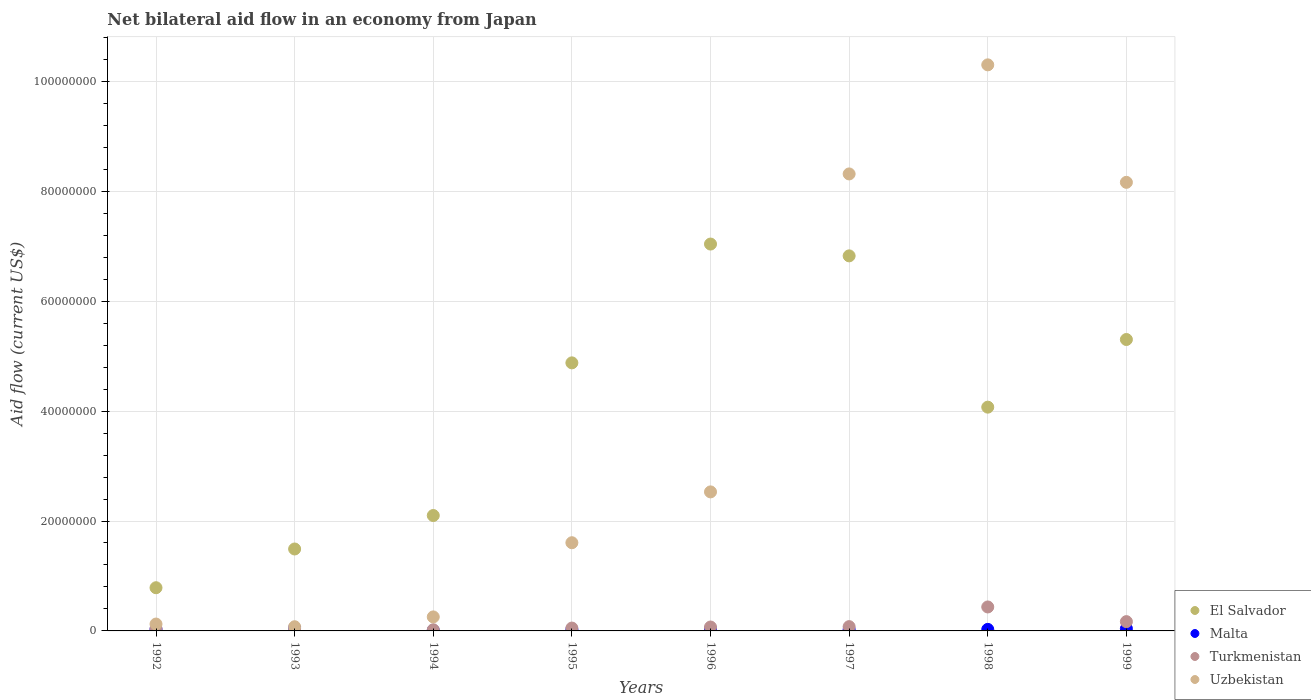What is the net bilateral aid flow in Malta in 1993?
Provide a succinct answer. 5.30e+05. Across all years, what is the maximum net bilateral aid flow in El Salvador?
Offer a very short reply. 7.04e+07. Across all years, what is the minimum net bilateral aid flow in Malta?
Provide a short and direct response. 9.00e+04. What is the total net bilateral aid flow in Turkmenistan in the graph?
Provide a short and direct response. 8.75e+06. What is the difference between the net bilateral aid flow in Malta in 1997 and that in 1998?
Keep it short and to the point. -2.00e+04. What is the difference between the net bilateral aid flow in Turkmenistan in 1997 and the net bilateral aid flow in Uzbekistan in 1995?
Ensure brevity in your answer.  -1.53e+07. What is the average net bilateral aid flow in El Salvador per year?
Offer a terse response. 4.06e+07. In the year 1993, what is the difference between the net bilateral aid flow in Malta and net bilateral aid flow in Uzbekistan?
Ensure brevity in your answer.  -2.30e+05. What is the ratio of the net bilateral aid flow in Turkmenistan in 1994 to that in 1995?
Provide a succinct answer. 0.4. Is the difference between the net bilateral aid flow in Malta in 1998 and 1999 greater than the difference between the net bilateral aid flow in Uzbekistan in 1998 and 1999?
Your response must be concise. No. What is the difference between the highest and the second highest net bilateral aid flow in Turkmenistan?
Your response must be concise. 2.67e+06. What is the difference between the highest and the lowest net bilateral aid flow in El Salvador?
Provide a short and direct response. 6.25e+07. In how many years, is the net bilateral aid flow in Malta greater than the average net bilateral aid flow in Malta taken over all years?
Offer a very short reply. 3. Is the sum of the net bilateral aid flow in Uzbekistan in 1993 and 1998 greater than the maximum net bilateral aid flow in Malta across all years?
Make the answer very short. Yes. Does the net bilateral aid flow in Turkmenistan monotonically increase over the years?
Offer a terse response. No. Is the net bilateral aid flow in Malta strictly greater than the net bilateral aid flow in El Salvador over the years?
Provide a short and direct response. No. Is the net bilateral aid flow in El Salvador strictly less than the net bilateral aid flow in Turkmenistan over the years?
Your answer should be very brief. No. How many dotlines are there?
Offer a terse response. 4. Does the graph contain grids?
Your answer should be very brief. Yes. Where does the legend appear in the graph?
Offer a very short reply. Bottom right. What is the title of the graph?
Ensure brevity in your answer.  Net bilateral aid flow in an economy from Japan. Does "El Salvador" appear as one of the legend labels in the graph?
Your response must be concise. Yes. What is the label or title of the X-axis?
Provide a short and direct response. Years. What is the Aid flow (current US$) in El Salvador in 1992?
Your answer should be compact. 7.86e+06. What is the Aid flow (current US$) of Uzbekistan in 1992?
Your answer should be compact. 1.25e+06. What is the Aid flow (current US$) in El Salvador in 1993?
Your answer should be very brief. 1.49e+07. What is the Aid flow (current US$) of Malta in 1993?
Offer a terse response. 5.30e+05. What is the Aid flow (current US$) of Uzbekistan in 1993?
Provide a short and direct response. 7.60e+05. What is the Aid flow (current US$) in El Salvador in 1994?
Provide a short and direct response. 2.10e+07. What is the Aid flow (current US$) of Malta in 1994?
Your response must be concise. 9.00e+04. What is the Aid flow (current US$) of Turkmenistan in 1994?
Your answer should be compact. 2.10e+05. What is the Aid flow (current US$) of Uzbekistan in 1994?
Give a very brief answer. 2.55e+06. What is the Aid flow (current US$) of El Salvador in 1995?
Your answer should be compact. 4.88e+07. What is the Aid flow (current US$) of Malta in 1995?
Provide a short and direct response. 2.40e+05. What is the Aid flow (current US$) in Turkmenistan in 1995?
Make the answer very short. 5.20e+05. What is the Aid flow (current US$) of Uzbekistan in 1995?
Your answer should be compact. 1.60e+07. What is the Aid flow (current US$) of El Salvador in 1996?
Offer a very short reply. 7.04e+07. What is the Aid flow (current US$) of Turkmenistan in 1996?
Your response must be concise. 7.10e+05. What is the Aid flow (current US$) in Uzbekistan in 1996?
Your answer should be compact. 2.53e+07. What is the Aid flow (current US$) in El Salvador in 1997?
Your response must be concise. 6.82e+07. What is the Aid flow (current US$) of Turkmenistan in 1997?
Keep it short and to the point. 7.80e+05. What is the Aid flow (current US$) of Uzbekistan in 1997?
Keep it short and to the point. 8.32e+07. What is the Aid flow (current US$) of El Salvador in 1998?
Keep it short and to the point. 4.07e+07. What is the Aid flow (current US$) in Turkmenistan in 1998?
Your answer should be compact. 4.36e+06. What is the Aid flow (current US$) in Uzbekistan in 1998?
Keep it short and to the point. 1.03e+08. What is the Aid flow (current US$) in El Salvador in 1999?
Your answer should be compact. 5.30e+07. What is the Aid flow (current US$) in Malta in 1999?
Ensure brevity in your answer.  4.20e+05. What is the Aid flow (current US$) of Turkmenistan in 1999?
Provide a short and direct response. 1.69e+06. What is the Aid flow (current US$) of Uzbekistan in 1999?
Offer a terse response. 8.16e+07. Across all years, what is the maximum Aid flow (current US$) of El Salvador?
Your answer should be compact. 7.04e+07. Across all years, what is the maximum Aid flow (current US$) in Malta?
Make the answer very short. 5.30e+05. Across all years, what is the maximum Aid flow (current US$) of Turkmenistan?
Provide a succinct answer. 4.36e+06. Across all years, what is the maximum Aid flow (current US$) in Uzbekistan?
Your response must be concise. 1.03e+08. Across all years, what is the minimum Aid flow (current US$) in El Salvador?
Offer a very short reply. 7.86e+06. Across all years, what is the minimum Aid flow (current US$) in Malta?
Your answer should be compact. 9.00e+04. Across all years, what is the minimum Aid flow (current US$) in Uzbekistan?
Provide a succinct answer. 7.60e+05. What is the total Aid flow (current US$) of El Salvador in the graph?
Your response must be concise. 3.25e+08. What is the total Aid flow (current US$) in Malta in the graph?
Keep it short and to the point. 2.49e+06. What is the total Aid flow (current US$) in Turkmenistan in the graph?
Keep it short and to the point. 8.75e+06. What is the total Aid flow (current US$) of Uzbekistan in the graph?
Offer a very short reply. 3.14e+08. What is the difference between the Aid flow (current US$) in El Salvador in 1992 and that in 1993?
Your answer should be compact. -7.05e+06. What is the difference between the Aid flow (current US$) in Malta in 1992 and that in 1993?
Offer a terse response. -2.30e+05. What is the difference between the Aid flow (current US$) of Turkmenistan in 1992 and that in 1993?
Ensure brevity in your answer.  3.00e+05. What is the difference between the Aid flow (current US$) of El Salvador in 1992 and that in 1994?
Your response must be concise. -1.31e+07. What is the difference between the Aid flow (current US$) of Uzbekistan in 1992 and that in 1994?
Your answer should be very brief. -1.30e+06. What is the difference between the Aid flow (current US$) of El Salvador in 1992 and that in 1995?
Provide a short and direct response. -4.09e+07. What is the difference between the Aid flow (current US$) in Malta in 1992 and that in 1995?
Offer a very short reply. 6.00e+04. What is the difference between the Aid flow (current US$) in Uzbekistan in 1992 and that in 1995?
Offer a very short reply. -1.48e+07. What is the difference between the Aid flow (current US$) of El Salvador in 1992 and that in 1996?
Ensure brevity in your answer.  -6.25e+07. What is the difference between the Aid flow (current US$) in Turkmenistan in 1992 and that in 1996?
Make the answer very short. -3.20e+05. What is the difference between the Aid flow (current US$) of Uzbekistan in 1992 and that in 1996?
Your answer should be compact. -2.40e+07. What is the difference between the Aid flow (current US$) in El Salvador in 1992 and that in 1997?
Your response must be concise. -6.04e+07. What is the difference between the Aid flow (current US$) of Turkmenistan in 1992 and that in 1997?
Your response must be concise. -3.90e+05. What is the difference between the Aid flow (current US$) of Uzbekistan in 1992 and that in 1997?
Offer a terse response. -8.19e+07. What is the difference between the Aid flow (current US$) in El Salvador in 1992 and that in 1998?
Your answer should be very brief. -3.29e+07. What is the difference between the Aid flow (current US$) in Malta in 1992 and that in 1998?
Provide a short and direct response. 2.00e+04. What is the difference between the Aid flow (current US$) in Turkmenistan in 1992 and that in 1998?
Your answer should be compact. -3.97e+06. What is the difference between the Aid flow (current US$) in Uzbekistan in 1992 and that in 1998?
Keep it short and to the point. -1.02e+08. What is the difference between the Aid flow (current US$) in El Salvador in 1992 and that in 1999?
Offer a terse response. -4.52e+07. What is the difference between the Aid flow (current US$) of Turkmenistan in 1992 and that in 1999?
Provide a short and direct response. -1.30e+06. What is the difference between the Aid flow (current US$) in Uzbekistan in 1992 and that in 1999?
Your answer should be compact. -8.04e+07. What is the difference between the Aid flow (current US$) of El Salvador in 1993 and that in 1994?
Offer a terse response. -6.09e+06. What is the difference between the Aid flow (current US$) in Malta in 1993 and that in 1994?
Provide a short and direct response. 4.40e+05. What is the difference between the Aid flow (current US$) of Turkmenistan in 1993 and that in 1994?
Give a very brief answer. -1.20e+05. What is the difference between the Aid flow (current US$) of Uzbekistan in 1993 and that in 1994?
Offer a very short reply. -1.79e+06. What is the difference between the Aid flow (current US$) of El Salvador in 1993 and that in 1995?
Your response must be concise. -3.39e+07. What is the difference between the Aid flow (current US$) of Malta in 1993 and that in 1995?
Give a very brief answer. 2.90e+05. What is the difference between the Aid flow (current US$) of Turkmenistan in 1993 and that in 1995?
Give a very brief answer. -4.30e+05. What is the difference between the Aid flow (current US$) of Uzbekistan in 1993 and that in 1995?
Provide a short and direct response. -1.53e+07. What is the difference between the Aid flow (current US$) of El Salvador in 1993 and that in 1996?
Your answer should be very brief. -5.55e+07. What is the difference between the Aid flow (current US$) of Turkmenistan in 1993 and that in 1996?
Make the answer very short. -6.20e+05. What is the difference between the Aid flow (current US$) in Uzbekistan in 1993 and that in 1996?
Your response must be concise. -2.45e+07. What is the difference between the Aid flow (current US$) in El Salvador in 1993 and that in 1997?
Your answer should be compact. -5.33e+07. What is the difference between the Aid flow (current US$) in Malta in 1993 and that in 1997?
Provide a short and direct response. 2.70e+05. What is the difference between the Aid flow (current US$) in Turkmenistan in 1993 and that in 1997?
Your answer should be compact. -6.90e+05. What is the difference between the Aid flow (current US$) in Uzbekistan in 1993 and that in 1997?
Your answer should be very brief. -8.24e+07. What is the difference between the Aid flow (current US$) of El Salvador in 1993 and that in 1998?
Your answer should be very brief. -2.58e+07. What is the difference between the Aid flow (current US$) of Malta in 1993 and that in 1998?
Your response must be concise. 2.50e+05. What is the difference between the Aid flow (current US$) in Turkmenistan in 1993 and that in 1998?
Offer a very short reply. -4.27e+06. What is the difference between the Aid flow (current US$) in Uzbekistan in 1993 and that in 1998?
Offer a terse response. -1.02e+08. What is the difference between the Aid flow (current US$) in El Salvador in 1993 and that in 1999?
Offer a very short reply. -3.81e+07. What is the difference between the Aid flow (current US$) of Turkmenistan in 1993 and that in 1999?
Ensure brevity in your answer.  -1.60e+06. What is the difference between the Aid flow (current US$) of Uzbekistan in 1993 and that in 1999?
Your answer should be very brief. -8.09e+07. What is the difference between the Aid flow (current US$) of El Salvador in 1994 and that in 1995?
Offer a terse response. -2.78e+07. What is the difference between the Aid flow (current US$) in Turkmenistan in 1994 and that in 1995?
Make the answer very short. -3.10e+05. What is the difference between the Aid flow (current US$) of Uzbekistan in 1994 and that in 1995?
Your response must be concise. -1.35e+07. What is the difference between the Aid flow (current US$) of El Salvador in 1994 and that in 1996?
Provide a short and direct response. -4.94e+07. What is the difference between the Aid flow (current US$) in Malta in 1994 and that in 1996?
Keep it short and to the point. -2.80e+05. What is the difference between the Aid flow (current US$) in Turkmenistan in 1994 and that in 1996?
Offer a terse response. -5.00e+05. What is the difference between the Aid flow (current US$) in Uzbekistan in 1994 and that in 1996?
Your answer should be very brief. -2.28e+07. What is the difference between the Aid flow (current US$) in El Salvador in 1994 and that in 1997?
Keep it short and to the point. -4.72e+07. What is the difference between the Aid flow (current US$) in Turkmenistan in 1994 and that in 1997?
Offer a very short reply. -5.70e+05. What is the difference between the Aid flow (current US$) in Uzbekistan in 1994 and that in 1997?
Your answer should be compact. -8.06e+07. What is the difference between the Aid flow (current US$) of El Salvador in 1994 and that in 1998?
Give a very brief answer. -1.97e+07. What is the difference between the Aid flow (current US$) in Malta in 1994 and that in 1998?
Your answer should be very brief. -1.90e+05. What is the difference between the Aid flow (current US$) of Turkmenistan in 1994 and that in 1998?
Give a very brief answer. -4.15e+06. What is the difference between the Aid flow (current US$) of Uzbekistan in 1994 and that in 1998?
Your response must be concise. -1.00e+08. What is the difference between the Aid flow (current US$) of El Salvador in 1994 and that in 1999?
Make the answer very short. -3.20e+07. What is the difference between the Aid flow (current US$) in Malta in 1994 and that in 1999?
Your answer should be compact. -3.30e+05. What is the difference between the Aid flow (current US$) of Turkmenistan in 1994 and that in 1999?
Keep it short and to the point. -1.48e+06. What is the difference between the Aid flow (current US$) in Uzbekistan in 1994 and that in 1999?
Ensure brevity in your answer.  -7.91e+07. What is the difference between the Aid flow (current US$) of El Salvador in 1995 and that in 1996?
Give a very brief answer. -2.16e+07. What is the difference between the Aid flow (current US$) of Turkmenistan in 1995 and that in 1996?
Your answer should be very brief. -1.90e+05. What is the difference between the Aid flow (current US$) in Uzbekistan in 1995 and that in 1996?
Provide a short and direct response. -9.25e+06. What is the difference between the Aid flow (current US$) of El Salvador in 1995 and that in 1997?
Offer a very short reply. -1.95e+07. What is the difference between the Aid flow (current US$) of Malta in 1995 and that in 1997?
Make the answer very short. -2.00e+04. What is the difference between the Aid flow (current US$) in Uzbekistan in 1995 and that in 1997?
Give a very brief answer. -6.71e+07. What is the difference between the Aid flow (current US$) in El Salvador in 1995 and that in 1998?
Your answer should be compact. 8.06e+06. What is the difference between the Aid flow (current US$) of Turkmenistan in 1995 and that in 1998?
Ensure brevity in your answer.  -3.84e+06. What is the difference between the Aid flow (current US$) of Uzbekistan in 1995 and that in 1998?
Give a very brief answer. -8.70e+07. What is the difference between the Aid flow (current US$) of El Salvador in 1995 and that in 1999?
Give a very brief answer. -4.25e+06. What is the difference between the Aid flow (current US$) in Malta in 1995 and that in 1999?
Keep it short and to the point. -1.80e+05. What is the difference between the Aid flow (current US$) of Turkmenistan in 1995 and that in 1999?
Provide a short and direct response. -1.17e+06. What is the difference between the Aid flow (current US$) of Uzbekistan in 1995 and that in 1999?
Ensure brevity in your answer.  -6.56e+07. What is the difference between the Aid flow (current US$) of El Salvador in 1996 and that in 1997?
Give a very brief answer. 2.15e+06. What is the difference between the Aid flow (current US$) in Malta in 1996 and that in 1997?
Your answer should be compact. 1.10e+05. What is the difference between the Aid flow (current US$) in Uzbekistan in 1996 and that in 1997?
Make the answer very short. -5.79e+07. What is the difference between the Aid flow (current US$) of El Salvador in 1996 and that in 1998?
Offer a terse response. 2.97e+07. What is the difference between the Aid flow (current US$) in Turkmenistan in 1996 and that in 1998?
Provide a succinct answer. -3.65e+06. What is the difference between the Aid flow (current US$) in Uzbekistan in 1996 and that in 1998?
Keep it short and to the point. -7.77e+07. What is the difference between the Aid flow (current US$) of El Salvador in 1996 and that in 1999?
Make the answer very short. 1.74e+07. What is the difference between the Aid flow (current US$) of Malta in 1996 and that in 1999?
Offer a terse response. -5.00e+04. What is the difference between the Aid flow (current US$) of Turkmenistan in 1996 and that in 1999?
Your answer should be compact. -9.80e+05. What is the difference between the Aid flow (current US$) in Uzbekistan in 1996 and that in 1999?
Keep it short and to the point. -5.63e+07. What is the difference between the Aid flow (current US$) in El Salvador in 1997 and that in 1998?
Keep it short and to the point. 2.75e+07. What is the difference between the Aid flow (current US$) of Turkmenistan in 1997 and that in 1998?
Your answer should be compact. -3.58e+06. What is the difference between the Aid flow (current US$) of Uzbekistan in 1997 and that in 1998?
Keep it short and to the point. -1.98e+07. What is the difference between the Aid flow (current US$) in El Salvador in 1997 and that in 1999?
Your response must be concise. 1.52e+07. What is the difference between the Aid flow (current US$) in Malta in 1997 and that in 1999?
Give a very brief answer. -1.60e+05. What is the difference between the Aid flow (current US$) in Turkmenistan in 1997 and that in 1999?
Your response must be concise. -9.10e+05. What is the difference between the Aid flow (current US$) of Uzbekistan in 1997 and that in 1999?
Ensure brevity in your answer.  1.53e+06. What is the difference between the Aid flow (current US$) in El Salvador in 1998 and that in 1999?
Provide a succinct answer. -1.23e+07. What is the difference between the Aid flow (current US$) of Turkmenistan in 1998 and that in 1999?
Make the answer very short. 2.67e+06. What is the difference between the Aid flow (current US$) of Uzbekistan in 1998 and that in 1999?
Your response must be concise. 2.14e+07. What is the difference between the Aid flow (current US$) of El Salvador in 1992 and the Aid flow (current US$) of Malta in 1993?
Your answer should be compact. 7.33e+06. What is the difference between the Aid flow (current US$) of El Salvador in 1992 and the Aid flow (current US$) of Turkmenistan in 1993?
Give a very brief answer. 7.77e+06. What is the difference between the Aid flow (current US$) of El Salvador in 1992 and the Aid flow (current US$) of Uzbekistan in 1993?
Your response must be concise. 7.10e+06. What is the difference between the Aid flow (current US$) of Malta in 1992 and the Aid flow (current US$) of Turkmenistan in 1993?
Your answer should be compact. 2.10e+05. What is the difference between the Aid flow (current US$) in Malta in 1992 and the Aid flow (current US$) in Uzbekistan in 1993?
Provide a succinct answer. -4.60e+05. What is the difference between the Aid flow (current US$) in Turkmenistan in 1992 and the Aid flow (current US$) in Uzbekistan in 1993?
Provide a short and direct response. -3.70e+05. What is the difference between the Aid flow (current US$) in El Salvador in 1992 and the Aid flow (current US$) in Malta in 1994?
Give a very brief answer. 7.77e+06. What is the difference between the Aid flow (current US$) in El Salvador in 1992 and the Aid flow (current US$) in Turkmenistan in 1994?
Your answer should be very brief. 7.65e+06. What is the difference between the Aid flow (current US$) of El Salvador in 1992 and the Aid flow (current US$) of Uzbekistan in 1994?
Offer a terse response. 5.31e+06. What is the difference between the Aid flow (current US$) of Malta in 1992 and the Aid flow (current US$) of Uzbekistan in 1994?
Provide a succinct answer. -2.25e+06. What is the difference between the Aid flow (current US$) of Turkmenistan in 1992 and the Aid flow (current US$) of Uzbekistan in 1994?
Ensure brevity in your answer.  -2.16e+06. What is the difference between the Aid flow (current US$) of El Salvador in 1992 and the Aid flow (current US$) of Malta in 1995?
Give a very brief answer. 7.62e+06. What is the difference between the Aid flow (current US$) in El Salvador in 1992 and the Aid flow (current US$) in Turkmenistan in 1995?
Provide a short and direct response. 7.34e+06. What is the difference between the Aid flow (current US$) in El Salvador in 1992 and the Aid flow (current US$) in Uzbekistan in 1995?
Provide a succinct answer. -8.19e+06. What is the difference between the Aid flow (current US$) of Malta in 1992 and the Aid flow (current US$) of Uzbekistan in 1995?
Provide a short and direct response. -1.58e+07. What is the difference between the Aid flow (current US$) of Turkmenistan in 1992 and the Aid flow (current US$) of Uzbekistan in 1995?
Offer a terse response. -1.57e+07. What is the difference between the Aid flow (current US$) in El Salvador in 1992 and the Aid flow (current US$) in Malta in 1996?
Make the answer very short. 7.49e+06. What is the difference between the Aid flow (current US$) in El Salvador in 1992 and the Aid flow (current US$) in Turkmenistan in 1996?
Give a very brief answer. 7.15e+06. What is the difference between the Aid flow (current US$) in El Salvador in 1992 and the Aid flow (current US$) in Uzbekistan in 1996?
Offer a terse response. -1.74e+07. What is the difference between the Aid flow (current US$) of Malta in 1992 and the Aid flow (current US$) of Turkmenistan in 1996?
Keep it short and to the point. -4.10e+05. What is the difference between the Aid flow (current US$) in Malta in 1992 and the Aid flow (current US$) in Uzbekistan in 1996?
Provide a succinct answer. -2.50e+07. What is the difference between the Aid flow (current US$) in Turkmenistan in 1992 and the Aid flow (current US$) in Uzbekistan in 1996?
Your answer should be compact. -2.49e+07. What is the difference between the Aid flow (current US$) in El Salvador in 1992 and the Aid flow (current US$) in Malta in 1997?
Offer a terse response. 7.60e+06. What is the difference between the Aid flow (current US$) of El Salvador in 1992 and the Aid flow (current US$) of Turkmenistan in 1997?
Offer a very short reply. 7.08e+06. What is the difference between the Aid flow (current US$) in El Salvador in 1992 and the Aid flow (current US$) in Uzbekistan in 1997?
Your response must be concise. -7.53e+07. What is the difference between the Aid flow (current US$) of Malta in 1992 and the Aid flow (current US$) of Turkmenistan in 1997?
Ensure brevity in your answer.  -4.80e+05. What is the difference between the Aid flow (current US$) in Malta in 1992 and the Aid flow (current US$) in Uzbekistan in 1997?
Provide a short and direct response. -8.29e+07. What is the difference between the Aid flow (current US$) in Turkmenistan in 1992 and the Aid flow (current US$) in Uzbekistan in 1997?
Your answer should be compact. -8.28e+07. What is the difference between the Aid flow (current US$) in El Salvador in 1992 and the Aid flow (current US$) in Malta in 1998?
Your answer should be compact. 7.58e+06. What is the difference between the Aid flow (current US$) of El Salvador in 1992 and the Aid flow (current US$) of Turkmenistan in 1998?
Your response must be concise. 3.50e+06. What is the difference between the Aid flow (current US$) of El Salvador in 1992 and the Aid flow (current US$) of Uzbekistan in 1998?
Your answer should be very brief. -9.52e+07. What is the difference between the Aid flow (current US$) of Malta in 1992 and the Aid flow (current US$) of Turkmenistan in 1998?
Keep it short and to the point. -4.06e+06. What is the difference between the Aid flow (current US$) in Malta in 1992 and the Aid flow (current US$) in Uzbekistan in 1998?
Provide a succinct answer. -1.03e+08. What is the difference between the Aid flow (current US$) in Turkmenistan in 1992 and the Aid flow (current US$) in Uzbekistan in 1998?
Provide a short and direct response. -1.03e+08. What is the difference between the Aid flow (current US$) of El Salvador in 1992 and the Aid flow (current US$) of Malta in 1999?
Your response must be concise. 7.44e+06. What is the difference between the Aid flow (current US$) of El Salvador in 1992 and the Aid flow (current US$) of Turkmenistan in 1999?
Make the answer very short. 6.17e+06. What is the difference between the Aid flow (current US$) in El Salvador in 1992 and the Aid flow (current US$) in Uzbekistan in 1999?
Keep it short and to the point. -7.38e+07. What is the difference between the Aid flow (current US$) of Malta in 1992 and the Aid flow (current US$) of Turkmenistan in 1999?
Offer a terse response. -1.39e+06. What is the difference between the Aid flow (current US$) in Malta in 1992 and the Aid flow (current US$) in Uzbekistan in 1999?
Ensure brevity in your answer.  -8.13e+07. What is the difference between the Aid flow (current US$) of Turkmenistan in 1992 and the Aid flow (current US$) of Uzbekistan in 1999?
Your answer should be very brief. -8.12e+07. What is the difference between the Aid flow (current US$) in El Salvador in 1993 and the Aid flow (current US$) in Malta in 1994?
Offer a terse response. 1.48e+07. What is the difference between the Aid flow (current US$) in El Salvador in 1993 and the Aid flow (current US$) in Turkmenistan in 1994?
Give a very brief answer. 1.47e+07. What is the difference between the Aid flow (current US$) in El Salvador in 1993 and the Aid flow (current US$) in Uzbekistan in 1994?
Provide a short and direct response. 1.24e+07. What is the difference between the Aid flow (current US$) of Malta in 1993 and the Aid flow (current US$) of Turkmenistan in 1994?
Provide a short and direct response. 3.20e+05. What is the difference between the Aid flow (current US$) in Malta in 1993 and the Aid flow (current US$) in Uzbekistan in 1994?
Offer a terse response. -2.02e+06. What is the difference between the Aid flow (current US$) in Turkmenistan in 1993 and the Aid flow (current US$) in Uzbekistan in 1994?
Ensure brevity in your answer.  -2.46e+06. What is the difference between the Aid flow (current US$) of El Salvador in 1993 and the Aid flow (current US$) of Malta in 1995?
Ensure brevity in your answer.  1.47e+07. What is the difference between the Aid flow (current US$) in El Salvador in 1993 and the Aid flow (current US$) in Turkmenistan in 1995?
Your answer should be very brief. 1.44e+07. What is the difference between the Aid flow (current US$) of El Salvador in 1993 and the Aid flow (current US$) of Uzbekistan in 1995?
Give a very brief answer. -1.14e+06. What is the difference between the Aid flow (current US$) in Malta in 1993 and the Aid flow (current US$) in Uzbekistan in 1995?
Offer a terse response. -1.55e+07. What is the difference between the Aid flow (current US$) of Turkmenistan in 1993 and the Aid flow (current US$) of Uzbekistan in 1995?
Your response must be concise. -1.60e+07. What is the difference between the Aid flow (current US$) of El Salvador in 1993 and the Aid flow (current US$) of Malta in 1996?
Give a very brief answer. 1.45e+07. What is the difference between the Aid flow (current US$) in El Salvador in 1993 and the Aid flow (current US$) in Turkmenistan in 1996?
Your answer should be very brief. 1.42e+07. What is the difference between the Aid flow (current US$) of El Salvador in 1993 and the Aid flow (current US$) of Uzbekistan in 1996?
Your response must be concise. -1.04e+07. What is the difference between the Aid flow (current US$) in Malta in 1993 and the Aid flow (current US$) in Uzbekistan in 1996?
Ensure brevity in your answer.  -2.48e+07. What is the difference between the Aid flow (current US$) in Turkmenistan in 1993 and the Aid flow (current US$) in Uzbekistan in 1996?
Provide a short and direct response. -2.52e+07. What is the difference between the Aid flow (current US$) in El Salvador in 1993 and the Aid flow (current US$) in Malta in 1997?
Your response must be concise. 1.46e+07. What is the difference between the Aid flow (current US$) of El Salvador in 1993 and the Aid flow (current US$) of Turkmenistan in 1997?
Make the answer very short. 1.41e+07. What is the difference between the Aid flow (current US$) of El Salvador in 1993 and the Aid flow (current US$) of Uzbekistan in 1997?
Offer a terse response. -6.82e+07. What is the difference between the Aid flow (current US$) in Malta in 1993 and the Aid flow (current US$) in Turkmenistan in 1997?
Keep it short and to the point. -2.50e+05. What is the difference between the Aid flow (current US$) of Malta in 1993 and the Aid flow (current US$) of Uzbekistan in 1997?
Your answer should be very brief. -8.26e+07. What is the difference between the Aid flow (current US$) in Turkmenistan in 1993 and the Aid flow (current US$) in Uzbekistan in 1997?
Your response must be concise. -8.31e+07. What is the difference between the Aid flow (current US$) of El Salvador in 1993 and the Aid flow (current US$) of Malta in 1998?
Provide a succinct answer. 1.46e+07. What is the difference between the Aid flow (current US$) of El Salvador in 1993 and the Aid flow (current US$) of Turkmenistan in 1998?
Offer a terse response. 1.06e+07. What is the difference between the Aid flow (current US$) in El Salvador in 1993 and the Aid flow (current US$) in Uzbekistan in 1998?
Offer a very short reply. -8.81e+07. What is the difference between the Aid flow (current US$) in Malta in 1993 and the Aid flow (current US$) in Turkmenistan in 1998?
Offer a very short reply. -3.83e+06. What is the difference between the Aid flow (current US$) of Malta in 1993 and the Aid flow (current US$) of Uzbekistan in 1998?
Your answer should be very brief. -1.02e+08. What is the difference between the Aid flow (current US$) of Turkmenistan in 1993 and the Aid flow (current US$) of Uzbekistan in 1998?
Your response must be concise. -1.03e+08. What is the difference between the Aid flow (current US$) in El Salvador in 1993 and the Aid flow (current US$) in Malta in 1999?
Your answer should be compact. 1.45e+07. What is the difference between the Aid flow (current US$) in El Salvador in 1993 and the Aid flow (current US$) in Turkmenistan in 1999?
Offer a terse response. 1.32e+07. What is the difference between the Aid flow (current US$) in El Salvador in 1993 and the Aid flow (current US$) in Uzbekistan in 1999?
Your response must be concise. -6.67e+07. What is the difference between the Aid flow (current US$) in Malta in 1993 and the Aid flow (current US$) in Turkmenistan in 1999?
Keep it short and to the point. -1.16e+06. What is the difference between the Aid flow (current US$) of Malta in 1993 and the Aid flow (current US$) of Uzbekistan in 1999?
Your answer should be compact. -8.11e+07. What is the difference between the Aid flow (current US$) in Turkmenistan in 1993 and the Aid flow (current US$) in Uzbekistan in 1999?
Provide a succinct answer. -8.15e+07. What is the difference between the Aid flow (current US$) in El Salvador in 1994 and the Aid flow (current US$) in Malta in 1995?
Your answer should be compact. 2.08e+07. What is the difference between the Aid flow (current US$) in El Salvador in 1994 and the Aid flow (current US$) in Turkmenistan in 1995?
Provide a short and direct response. 2.05e+07. What is the difference between the Aid flow (current US$) of El Salvador in 1994 and the Aid flow (current US$) of Uzbekistan in 1995?
Your answer should be very brief. 4.95e+06. What is the difference between the Aid flow (current US$) of Malta in 1994 and the Aid flow (current US$) of Turkmenistan in 1995?
Offer a terse response. -4.30e+05. What is the difference between the Aid flow (current US$) of Malta in 1994 and the Aid flow (current US$) of Uzbekistan in 1995?
Keep it short and to the point. -1.60e+07. What is the difference between the Aid flow (current US$) of Turkmenistan in 1994 and the Aid flow (current US$) of Uzbekistan in 1995?
Keep it short and to the point. -1.58e+07. What is the difference between the Aid flow (current US$) in El Salvador in 1994 and the Aid flow (current US$) in Malta in 1996?
Offer a very short reply. 2.06e+07. What is the difference between the Aid flow (current US$) in El Salvador in 1994 and the Aid flow (current US$) in Turkmenistan in 1996?
Ensure brevity in your answer.  2.03e+07. What is the difference between the Aid flow (current US$) in El Salvador in 1994 and the Aid flow (current US$) in Uzbekistan in 1996?
Give a very brief answer. -4.30e+06. What is the difference between the Aid flow (current US$) of Malta in 1994 and the Aid flow (current US$) of Turkmenistan in 1996?
Your answer should be very brief. -6.20e+05. What is the difference between the Aid flow (current US$) of Malta in 1994 and the Aid flow (current US$) of Uzbekistan in 1996?
Provide a short and direct response. -2.52e+07. What is the difference between the Aid flow (current US$) in Turkmenistan in 1994 and the Aid flow (current US$) in Uzbekistan in 1996?
Keep it short and to the point. -2.51e+07. What is the difference between the Aid flow (current US$) of El Salvador in 1994 and the Aid flow (current US$) of Malta in 1997?
Keep it short and to the point. 2.07e+07. What is the difference between the Aid flow (current US$) of El Salvador in 1994 and the Aid flow (current US$) of Turkmenistan in 1997?
Your response must be concise. 2.02e+07. What is the difference between the Aid flow (current US$) of El Salvador in 1994 and the Aid flow (current US$) of Uzbekistan in 1997?
Make the answer very short. -6.22e+07. What is the difference between the Aid flow (current US$) of Malta in 1994 and the Aid flow (current US$) of Turkmenistan in 1997?
Ensure brevity in your answer.  -6.90e+05. What is the difference between the Aid flow (current US$) in Malta in 1994 and the Aid flow (current US$) in Uzbekistan in 1997?
Provide a short and direct response. -8.31e+07. What is the difference between the Aid flow (current US$) in Turkmenistan in 1994 and the Aid flow (current US$) in Uzbekistan in 1997?
Provide a short and direct response. -8.30e+07. What is the difference between the Aid flow (current US$) of El Salvador in 1994 and the Aid flow (current US$) of Malta in 1998?
Offer a terse response. 2.07e+07. What is the difference between the Aid flow (current US$) in El Salvador in 1994 and the Aid flow (current US$) in Turkmenistan in 1998?
Give a very brief answer. 1.66e+07. What is the difference between the Aid flow (current US$) of El Salvador in 1994 and the Aid flow (current US$) of Uzbekistan in 1998?
Your answer should be compact. -8.20e+07. What is the difference between the Aid flow (current US$) of Malta in 1994 and the Aid flow (current US$) of Turkmenistan in 1998?
Make the answer very short. -4.27e+06. What is the difference between the Aid flow (current US$) in Malta in 1994 and the Aid flow (current US$) in Uzbekistan in 1998?
Make the answer very short. -1.03e+08. What is the difference between the Aid flow (current US$) of Turkmenistan in 1994 and the Aid flow (current US$) of Uzbekistan in 1998?
Your response must be concise. -1.03e+08. What is the difference between the Aid flow (current US$) of El Salvador in 1994 and the Aid flow (current US$) of Malta in 1999?
Give a very brief answer. 2.06e+07. What is the difference between the Aid flow (current US$) of El Salvador in 1994 and the Aid flow (current US$) of Turkmenistan in 1999?
Provide a short and direct response. 1.93e+07. What is the difference between the Aid flow (current US$) of El Salvador in 1994 and the Aid flow (current US$) of Uzbekistan in 1999?
Offer a very short reply. -6.06e+07. What is the difference between the Aid flow (current US$) of Malta in 1994 and the Aid flow (current US$) of Turkmenistan in 1999?
Your response must be concise. -1.60e+06. What is the difference between the Aid flow (current US$) in Malta in 1994 and the Aid flow (current US$) in Uzbekistan in 1999?
Your response must be concise. -8.15e+07. What is the difference between the Aid flow (current US$) in Turkmenistan in 1994 and the Aid flow (current US$) in Uzbekistan in 1999?
Give a very brief answer. -8.14e+07. What is the difference between the Aid flow (current US$) of El Salvador in 1995 and the Aid flow (current US$) of Malta in 1996?
Offer a terse response. 4.84e+07. What is the difference between the Aid flow (current US$) of El Salvador in 1995 and the Aid flow (current US$) of Turkmenistan in 1996?
Make the answer very short. 4.81e+07. What is the difference between the Aid flow (current US$) of El Salvador in 1995 and the Aid flow (current US$) of Uzbekistan in 1996?
Keep it short and to the point. 2.35e+07. What is the difference between the Aid flow (current US$) in Malta in 1995 and the Aid flow (current US$) in Turkmenistan in 1996?
Your response must be concise. -4.70e+05. What is the difference between the Aid flow (current US$) in Malta in 1995 and the Aid flow (current US$) in Uzbekistan in 1996?
Your answer should be compact. -2.51e+07. What is the difference between the Aid flow (current US$) in Turkmenistan in 1995 and the Aid flow (current US$) in Uzbekistan in 1996?
Offer a very short reply. -2.48e+07. What is the difference between the Aid flow (current US$) in El Salvador in 1995 and the Aid flow (current US$) in Malta in 1997?
Give a very brief answer. 4.85e+07. What is the difference between the Aid flow (current US$) in El Salvador in 1995 and the Aid flow (current US$) in Turkmenistan in 1997?
Offer a terse response. 4.80e+07. What is the difference between the Aid flow (current US$) of El Salvador in 1995 and the Aid flow (current US$) of Uzbekistan in 1997?
Make the answer very short. -3.44e+07. What is the difference between the Aid flow (current US$) in Malta in 1995 and the Aid flow (current US$) in Turkmenistan in 1997?
Your answer should be compact. -5.40e+05. What is the difference between the Aid flow (current US$) in Malta in 1995 and the Aid flow (current US$) in Uzbekistan in 1997?
Your answer should be very brief. -8.29e+07. What is the difference between the Aid flow (current US$) of Turkmenistan in 1995 and the Aid flow (current US$) of Uzbekistan in 1997?
Your answer should be compact. -8.26e+07. What is the difference between the Aid flow (current US$) of El Salvador in 1995 and the Aid flow (current US$) of Malta in 1998?
Your answer should be compact. 4.85e+07. What is the difference between the Aid flow (current US$) of El Salvador in 1995 and the Aid flow (current US$) of Turkmenistan in 1998?
Keep it short and to the point. 4.44e+07. What is the difference between the Aid flow (current US$) of El Salvador in 1995 and the Aid flow (current US$) of Uzbekistan in 1998?
Give a very brief answer. -5.42e+07. What is the difference between the Aid flow (current US$) in Malta in 1995 and the Aid flow (current US$) in Turkmenistan in 1998?
Ensure brevity in your answer.  -4.12e+06. What is the difference between the Aid flow (current US$) of Malta in 1995 and the Aid flow (current US$) of Uzbekistan in 1998?
Offer a terse response. -1.03e+08. What is the difference between the Aid flow (current US$) of Turkmenistan in 1995 and the Aid flow (current US$) of Uzbekistan in 1998?
Your response must be concise. -1.02e+08. What is the difference between the Aid flow (current US$) of El Salvador in 1995 and the Aid flow (current US$) of Malta in 1999?
Give a very brief answer. 4.84e+07. What is the difference between the Aid flow (current US$) of El Salvador in 1995 and the Aid flow (current US$) of Turkmenistan in 1999?
Your response must be concise. 4.71e+07. What is the difference between the Aid flow (current US$) of El Salvador in 1995 and the Aid flow (current US$) of Uzbekistan in 1999?
Offer a terse response. -3.28e+07. What is the difference between the Aid flow (current US$) in Malta in 1995 and the Aid flow (current US$) in Turkmenistan in 1999?
Provide a short and direct response. -1.45e+06. What is the difference between the Aid flow (current US$) of Malta in 1995 and the Aid flow (current US$) of Uzbekistan in 1999?
Your answer should be very brief. -8.14e+07. What is the difference between the Aid flow (current US$) in Turkmenistan in 1995 and the Aid flow (current US$) in Uzbekistan in 1999?
Give a very brief answer. -8.11e+07. What is the difference between the Aid flow (current US$) of El Salvador in 1996 and the Aid flow (current US$) of Malta in 1997?
Provide a succinct answer. 7.01e+07. What is the difference between the Aid flow (current US$) in El Salvador in 1996 and the Aid flow (current US$) in Turkmenistan in 1997?
Provide a succinct answer. 6.96e+07. What is the difference between the Aid flow (current US$) in El Salvador in 1996 and the Aid flow (current US$) in Uzbekistan in 1997?
Give a very brief answer. -1.28e+07. What is the difference between the Aid flow (current US$) of Malta in 1996 and the Aid flow (current US$) of Turkmenistan in 1997?
Your response must be concise. -4.10e+05. What is the difference between the Aid flow (current US$) of Malta in 1996 and the Aid flow (current US$) of Uzbekistan in 1997?
Make the answer very short. -8.28e+07. What is the difference between the Aid flow (current US$) of Turkmenistan in 1996 and the Aid flow (current US$) of Uzbekistan in 1997?
Your answer should be compact. -8.24e+07. What is the difference between the Aid flow (current US$) of El Salvador in 1996 and the Aid flow (current US$) of Malta in 1998?
Your answer should be compact. 7.01e+07. What is the difference between the Aid flow (current US$) in El Salvador in 1996 and the Aid flow (current US$) in Turkmenistan in 1998?
Offer a very short reply. 6.60e+07. What is the difference between the Aid flow (current US$) of El Salvador in 1996 and the Aid flow (current US$) of Uzbekistan in 1998?
Offer a terse response. -3.26e+07. What is the difference between the Aid flow (current US$) of Malta in 1996 and the Aid flow (current US$) of Turkmenistan in 1998?
Give a very brief answer. -3.99e+06. What is the difference between the Aid flow (current US$) of Malta in 1996 and the Aid flow (current US$) of Uzbekistan in 1998?
Provide a short and direct response. -1.03e+08. What is the difference between the Aid flow (current US$) of Turkmenistan in 1996 and the Aid flow (current US$) of Uzbekistan in 1998?
Make the answer very short. -1.02e+08. What is the difference between the Aid flow (current US$) in El Salvador in 1996 and the Aid flow (current US$) in Malta in 1999?
Provide a short and direct response. 7.00e+07. What is the difference between the Aid flow (current US$) in El Salvador in 1996 and the Aid flow (current US$) in Turkmenistan in 1999?
Give a very brief answer. 6.87e+07. What is the difference between the Aid flow (current US$) of El Salvador in 1996 and the Aid flow (current US$) of Uzbekistan in 1999?
Give a very brief answer. -1.12e+07. What is the difference between the Aid flow (current US$) in Malta in 1996 and the Aid flow (current US$) in Turkmenistan in 1999?
Offer a very short reply. -1.32e+06. What is the difference between the Aid flow (current US$) in Malta in 1996 and the Aid flow (current US$) in Uzbekistan in 1999?
Offer a terse response. -8.13e+07. What is the difference between the Aid flow (current US$) in Turkmenistan in 1996 and the Aid flow (current US$) in Uzbekistan in 1999?
Offer a terse response. -8.09e+07. What is the difference between the Aid flow (current US$) in El Salvador in 1997 and the Aid flow (current US$) in Malta in 1998?
Your answer should be very brief. 6.80e+07. What is the difference between the Aid flow (current US$) of El Salvador in 1997 and the Aid flow (current US$) of Turkmenistan in 1998?
Give a very brief answer. 6.39e+07. What is the difference between the Aid flow (current US$) of El Salvador in 1997 and the Aid flow (current US$) of Uzbekistan in 1998?
Your answer should be compact. -3.48e+07. What is the difference between the Aid flow (current US$) of Malta in 1997 and the Aid flow (current US$) of Turkmenistan in 1998?
Keep it short and to the point. -4.10e+06. What is the difference between the Aid flow (current US$) of Malta in 1997 and the Aid flow (current US$) of Uzbekistan in 1998?
Keep it short and to the point. -1.03e+08. What is the difference between the Aid flow (current US$) in Turkmenistan in 1997 and the Aid flow (current US$) in Uzbekistan in 1998?
Offer a terse response. -1.02e+08. What is the difference between the Aid flow (current US$) of El Salvador in 1997 and the Aid flow (current US$) of Malta in 1999?
Your response must be concise. 6.78e+07. What is the difference between the Aid flow (current US$) in El Salvador in 1997 and the Aid flow (current US$) in Turkmenistan in 1999?
Give a very brief answer. 6.66e+07. What is the difference between the Aid flow (current US$) of El Salvador in 1997 and the Aid flow (current US$) of Uzbekistan in 1999?
Keep it short and to the point. -1.34e+07. What is the difference between the Aid flow (current US$) in Malta in 1997 and the Aid flow (current US$) in Turkmenistan in 1999?
Keep it short and to the point. -1.43e+06. What is the difference between the Aid flow (current US$) of Malta in 1997 and the Aid flow (current US$) of Uzbekistan in 1999?
Offer a terse response. -8.14e+07. What is the difference between the Aid flow (current US$) of Turkmenistan in 1997 and the Aid flow (current US$) of Uzbekistan in 1999?
Your response must be concise. -8.08e+07. What is the difference between the Aid flow (current US$) in El Salvador in 1998 and the Aid flow (current US$) in Malta in 1999?
Offer a terse response. 4.03e+07. What is the difference between the Aid flow (current US$) in El Salvador in 1998 and the Aid flow (current US$) in Turkmenistan in 1999?
Provide a short and direct response. 3.90e+07. What is the difference between the Aid flow (current US$) in El Salvador in 1998 and the Aid flow (current US$) in Uzbekistan in 1999?
Offer a very short reply. -4.09e+07. What is the difference between the Aid flow (current US$) in Malta in 1998 and the Aid flow (current US$) in Turkmenistan in 1999?
Provide a short and direct response. -1.41e+06. What is the difference between the Aid flow (current US$) of Malta in 1998 and the Aid flow (current US$) of Uzbekistan in 1999?
Provide a succinct answer. -8.14e+07. What is the difference between the Aid flow (current US$) in Turkmenistan in 1998 and the Aid flow (current US$) in Uzbekistan in 1999?
Make the answer very short. -7.73e+07. What is the average Aid flow (current US$) of El Salvador per year?
Your response must be concise. 4.06e+07. What is the average Aid flow (current US$) in Malta per year?
Keep it short and to the point. 3.11e+05. What is the average Aid flow (current US$) of Turkmenistan per year?
Your answer should be compact. 1.09e+06. What is the average Aid flow (current US$) of Uzbekistan per year?
Offer a terse response. 3.92e+07. In the year 1992, what is the difference between the Aid flow (current US$) of El Salvador and Aid flow (current US$) of Malta?
Offer a very short reply. 7.56e+06. In the year 1992, what is the difference between the Aid flow (current US$) in El Salvador and Aid flow (current US$) in Turkmenistan?
Offer a terse response. 7.47e+06. In the year 1992, what is the difference between the Aid flow (current US$) in El Salvador and Aid flow (current US$) in Uzbekistan?
Provide a short and direct response. 6.61e+06. In the year 1992, what is the difference between the Aid flow (current US$) in Malta and Aid flow (current US$) in Turkmenistan?
Make the answer very short. -9.00e+04. In the year 1992, what is the difference between the Aid flow (current US$) of Malta and Aid flow (current US$) of Uzbekistan?
Provide a short and direct response. -9.50e+05. In the year 1992, what is the difference between the Aid flow (current US$) of Turkmenistan and Aid flow (current US$) of Uzbekistan?
Provide a short and direct response. -8.60e+05. In the year 1993, what is the difference between the Aid flow (current US$) of El Salvador and Aid flow (current US$) of Malta?
Offer a very short reply. 1.44e+07. In the year 1993, what is the difference between the Aid flow (current US$) of El Salvador and Aid flow (current US$) of Turkmenistan?
Give a very brief answer. 1.48e+07. In the year 1993, what is the difference between the Aid flow (current US$) of El Salvador and Aid flow (current US$) of Uzbekistan?
Offer a very short reply. 1.42e+07. In the year 1993, what is the difference between the Aid flow (current US$) of Malta and Aid flow (current US$) of Uzbekistan?
Your answer should be compact. -2.30e+05. In the year 1993, what is the difference between the Aid flow (current US$) in Turkmenistan and Aid flow (current US$) in Uzbekistan?
Make the answer very short. -6.70e+05. In the year 1994, what is the difference between the Aid flow (current US$) in El Salvador and Aid flow (current US$) in Malta?
Provide a short and direct response. 2.09e+07. In the year 1994, what is the difference between the Aid flow (current US$) of El Salvador and Aid flow (current US$) of Turkmenistan?
Your answer should be compact. 2.08e+07. In the year 1994, what is the difference between the Aid flow (current US$) of El Salvador and Aid flow (current US$) of Uzbekistan?
Your answer should be very brief. 1.84e+07. In the year 1994, what is the difference between the Aid flow (current US$) of Malta and Aid flow (current US$) of Uzbekistan?
Keep it short and to the point. -2.46e+06. In the year 1994, what is the difference between the Aid flow (current US$) in Turkmenistan and Aid flow (current US$) in Uzbekistan?
Provide a succinct answer. -2.34e+06. In the year 1995, what is the difference between the Aid flow (current US$) in El Salvador and Aid flow (current US$) in Malta?
Offer a very short reply. 4.85e+07. In the year 1995, what is the difference between the Aid flow (current US$) in El Salvador and Aid flow (current US$) in Turkmenistan?
Give a very brief answer. 4.83e+07. In the year 1995, what is the difference between the Aid flow (current US$) of El Salvador and Aid flow (current US$) of Uzbekistan?
Your answer should be compact. 3.27e+07. In the year 1995, what is the difference between the Aid flow (current US$) of Malta and Aid flow (current US$) of Turkmenistan?
Your answer should be very brief. -2.80e+05. In the year 1995, what is the difference between the Aid flow (current US$) of Malta and Aid flow (current US$) of Uzbekistan?
Your answer should be very brief. -1.58e+07. In the year 1995, what is the difference between the Aid flow (current US$) of Turkmenistan and Aid flow (current US$) of Uzbekistan?
Your answer should be very brief. -1.55e+07. In the year 1996, what is the difference between the Aid flow (current US$) in El Salvador and Aid flow (current US$) in Malta?
Provide a short and direct response. 7.00e+07. In the year 1996, what is the difference between the Aid flow (current US$) in El Salvador and Aid flow (current US$) in Turkmenistan?
Keep it short and to the point. 6.97e+07. In the year 1996, what is the difference between the Aid flow (current US$) in El Salvador and Aid flow (current US$) in Uzbekistan?
Your response must be concise. 4.51e+07. In the year 1996, what is the difference between the Aid flow (current US$) of Malta and Aid flow (current US$) of Uzbekistan?
Make the answer very short. -2.49e+07. In the year 1996, what is the difference between the Aid flow (current US$) in Turkmenistan and Aid flow (current US$) in Uzbekistan?
Offer a terse response. -2.46e+07. In the year 1997, what is the difference between the Aid flow (current US$) in El Salvador and Aid flow (current US$) in Malta?
Provide a succinct answer. 6.80e+07. In the year 1997, what is the difference between the Aid flow (current US$) of El Salvador and Aid flow (current US$) of Turkmenistan?
Your response must be concise. 6.75e+07. In the year 1997, what is the difference between the Aid flow (current US$) of El Salvador and Aid flow (current US$) of Uzbekistan?
Offer a very short reply. -1.49e+07. In the year 1997, what is the difference between the Aid flow (current US$) in Malta and Aid flow (current US$) in Turkmenistan?
Provide a succinct answer. -5.20e+05. In the year 1997, what is the difference between the Aid flow (current US$) in Malta and Aid flow (current US$) in Uzbekistan?
Keep it short and to the point. -8.29e+07. In the year 1997, what is the difference between the Aid flow (current US$) of Turkmenistan and Aid flow (current US$) of Uzbekistan?
Offer a very short reply. -8.24e+07. In the year 1998, what is the difference between the Aid flow (current US$) in El Salvador and Aid flow (current US$) in Malta?
Offer a very short reply. 4.04e+07. In the year 1998, what is the difference between the Aid flow (current US$) in El Salvador and Aid flow (current US$) in Turkmenistan?
Ensure brevity in your answer.  3.64e+07. In the year 1998, what is the difference between the Aid flow (current US$) in El Salvador and Aid flow (current US$) in Uzbekistan?
Your answer should be compact. -6.23e+07. In the year 1998, what is the difference between the Aid flow (current US$) of Malta and Aid flow (current US$) of Turkmenistan?
Ensure brevity in your answer.  -4.08e+06. In the year 1998, what is the difference between the Aid flow (current US$) in Malta and Aid flow (current US$) in Uzbekistan?
Your answer should be compact. -1.03e+08. In the year 1998, what is the difference between the Aid flow (current US$) in Turkmenistan and Aid flow (current US$) in Uzbekistan?
Make the answer very short. -9.86e+07. In the year 1999, what is the difference between the Aid flow (current US$) of El Salvador and Aid flow (current US$) of Malta?
Ensure brevity in your answer.  5.26e+07. In the year 1999, what is the difference between the Aid flow (current US$) in El Salvador and Aid flow (current US$) in Turkmenistan?
Your response must be concise. 5.13e+07. In the year 1999, what is the difference between the Aid flow (current US$) of El Salvador and Aid flow (current US$) of Uzbekistan?
Ensure brevity in your answer.  -2.86e+07. In the year 1999, what is the difference between the Aid flow (current US$) of Malta and Aid flow (current US$) of Turkmenistan?
Keep it short and to the point. -1.27e+06. In the year 1999, what is the difference between the Aid flow (current US$) in Malta and Aid flow (current US$) in Uzbekistan?
Provide a succinct answer. -8.12e+07. In the year 1999, what is the difference between the Aid flow (current US$) in Turkmenistan and Aid flow (current US$) in Uzbekistan?
Your answer should be very brief. -7.99e+07. What is the ratio of the Aid flow (current US$) in El Salvador in 1992 to that in 1993?
Your answer should be very brief. 0.53. What is the ratio of the Aid flow (current US$) of Malta in 1992 to that in 1993?
Make the answer very short. 0.57. What is the ratio of the Aid flow (current US$) in Turkmenistan in 1992 to that in 1993?
Provide a succinct answer. 4.33. What is the ratio of the Aid flow (current US$) in Uzbekistan in 1992 to that in 1993?
Your answer should be compact. 1.64. What is the ratio of the Aid flow (current US$) of El Salvador in 1992 to that in 1994?
Offer a terse response. 0.37. What is the ratio of the Aid flow (current US$) of Malta in 1992 to that in 1994?
Your answer should be very brief. 3.33. What is the ratio of the Aid flow (current US$) of Turkmenistan in 1992 to that in 1994?
Provide a succinct answer. 1.86. What is the ratio of the Aid flow (current US$) of Uzbekistan in 1992 to that in 1994?
Keep it short and to the point. 0.49. What is the ratio of the Aid flow (current US$) in El Salvador in 1992 to that in 1995?
Offer a very short reply. 0.16. What is the ratio of the Aid flow (current US$) in Turkmenistan in 1992 to that in 1995?
Provide a succinct answer. 0.75. What is the ratio of the Aid flow (current US$) of Uzbekistan in 1992 to that in 1995?
Provide a short and direct response. 0.08. What is the ratio of the Aid flow (current US$) in El Salvador in 1992 to that in 1996?
Provide a succinct answer. 0.11. What is the ratio of the Aid flow (current US$) of Malta in 1992 to that in 1996?
Make the answer very short. 0.81. What is the ratio of the Aid flow (current US$) of Turkmenistan in 1992 to that in 1996?
Your answer should be very brief. 0.55. What is the ratio of the Aid flow (current US$) of Uzbekistan in 1992 to that in 1996?
Provide a succinct answer. 0.05. What is the ratio of the Aid flow (current US$) of El Salvador in 1992 to that in 1997?
Ensure brevity in your answer.  0.12. What is the ratio of the Aid flow (current US$) in Malta in 1992 to that in 1997?
Keep it short and to the point. 1.15. What is the ratio of the Aid flow (current US$) of Uzbekistan in 1992 to that in 1997?
Offer a very short reply. 0.01. What is the ratio of the Aid flow (current US$) of El Salvador in 1992 to that in 1998?
Keep it short and to the point. 0.19. What is the ratio of the Aid flow (current US$) of Malta in 1992 to that in 1998?
Give a very brief answer. 1.07. What is the ratio of the Aid flow (current US$) in Turkmenistan in 1992 to that in 1998?
Your answer should be very brief. 0.09. What is the ratio of the Aid flow (current US$) in Uzbekistan in 1992 to that in 1998?
Make the answer very short. 0.01. What is the ratio of the Aid flow (current US$) in El Salvador in 1992 to that in 1999?
Offer a terse response. 0.15. What is the ratio of the Aid flow (current US$) in Malta in 1992 to that in 1999?
Offer a very short reply. 0.71. What is the ratio of the Aid flow (current US$) in Turkmenistan in 1992 to that in 1999?
Offer a terse response. 0.23. What is the ratio of the Aid flow (current US$) of Uzbekistan in 1992 to that in 1999?
Provide a short and direct response. 0.02. What is the ratio of the Aid flow (current US$) in El Salvador in 1993 to that in 1994?
Offer a very short reply. 0.71. What is the ratio of the Aid flow (current US$) in Malta in 1993 to that in 1994?
Ensure brevity in your answer.  5.89. What is the ratio of the Aid flow (current US$) in Turkmenistan in 1993 to that in 1994?
Ensure brevity in your answer.  0.43. What is the ratio of the Aid flow (current US$) in Uzbekistan in 1993 to that in 1994?
Your answer should be compact. 0.3. What is the ratio of the Aid flow (current US$) of El Salvador in 1993 to that in 1995?
Your answer should be very brief. 0.31. What is the ratio of the Aid flow (current US$) in Malta in 1993 to that in 1995?
Provide a succinct answer. 2.21. What is the ratio of the Aid flow (current US$) in Turkmenistan in 1993 to that in 1995?
Provide a succinct answer. 0.17. What is the ratio of the Aid flow (current US$) in Uzbekistan in 1993 to that in 1995?
Provide a short and direct response. 0.05. What is the ratio of the Aid flow (current US$) of El Salvador in 1993 to that in 1996?
Your response must be concise. 0.21. What is the ratio of the Aid flow (current US$) of Malta in 1993 to that in 1996?
Your answer should be very brief. 1.43. What is the ratio of the Aid flow (current US$) of Turkmenistan in 1993 to that in 1996?
Your response must be concise. 0.13. What is the ratio of the Aid flow (current US$) in El Salvador in 1993 to that in 1997?
Offer a very short reply. 0.22. What is the ratio of the Aid flow (current US$) of Malta in 1993 to that in 1997?
Keep it short and to the point. 2.04. What is the ratio of the Aid flow (current US$) in Turkmenistan in 1993 to that in 1997?
Offer a terse response. 0.12. What is the ratio of the Aid flow (current US$) of Uzbekistan in 1993 to that in 1997?
Your response must be concise. 0.01. What is the ratio of the Aid flow (current US$) in El Salvador in 1993 to that in 1998?
Make the answer very short. 0.37. What is the ratio of the Aid flow (current US$) of Malta in 1993 to that in 1998?
Provide a succinct answer. 1.89. What is the ratio of the Aid flow (current US$) of Turkmenistan in 1993 to that in 1998?
Your response must be concise. 0.02. What is the ratio of the Aid flow (current US$) in Uzbekistan in 1993 to that in 1998?
Offer a terse response. 0.01. What is the ratio of the Aid flow (current US$) of El Salvador in 1993 to that in 1999?
Provide a succinct answer. 0.28. What is the ratio of the Aid flow (current US$) of Malta in 1993 to that in 1999?
Your answer should be very brief. 1.26. What is the ratio of the Aid flow (current US$) of Turkmenistan in 1993 to that in 1999?
Provide a short and direct response. 0.05. What is the ratio of the Aid flow (current US$) of Uzbekistan in 1993 to that in 1999?
Offer a very short reply. 0.01. What is the ratio of the Aid flow (current US$) in El Salvador in 1994 to that in 1995?
Offer a terse response. 0.43. What is the ratio of the Aid flow (current US$) in Malta in 1994 to that in 1995?
Offer a terse response. 0.38. What is the ratio of the Aid flow (current US$) of Turkmenistan in 1994 to that in 1995?
Provide a succinct answer. 0.4. What is the ratio of the Aid flow (current US$) in Uzbekistan in 1994 to that in 1995?
Keep it short and to the point. 0.16. What is the ratio of the Aid flow (current US$) of El Salvador in 1994 to that in 1996?
Ensure brevity in your answer.  0.3. What is the ratio of the Aid flow (current US$) in Malta in 1994 to that in 1996?
Make the answer very short. 0.24. What is the ratio of the Aid flow (current US$) of Turkmenistan in 1994 to that in 1996?
Your response must be concise. 0.3. What is the ratio of the Aid flow (current US$) of Uzbekistan in 1994 to that in 1996?
Your response must be concise. 0.1. What is the ratio of the Aid flow (current US$) of El Salvador in 1994 to that in 1997?
Your response must be concise. 0.31. What is the ratio of the Aid flow (current US$) in Malta in 1994 to that in 1997?
Offer a terse response. 0.35. What is the ratio of the Aid flow (current US$) in Turkmenistan in 1994 to that in 1997?
Your answer should be compact. 0.27. What is the ratio of the Aid flow (current US$) in Uzbekistan in 1994 to that in 1997?
Offer a very short reply. 0.03. What is the ratio of the Aid flow (current US$) of El Salvador in 1994 to that in 1998?
Make the answer very short. 0.52. What is the ratio of the Aid flow (current US$) of Malta in 1994 to that in 1998?
Your answer should be compact. 0.32. What is the ratio of the Aid flow (current US$) of Turkmenistan in 1994 to that in 1998?
Your answer should be compact. 0.05. What is the ratio of the Aid flow (current US$) of Uzbekistan in 1994 to that in 1998?
Provide a succinct answer. 0.02. What is the ratio of the Aid flow (current US$) in El Salvador in 1994 to that in 1999?
Provide a short and direct response. 0.4. What is the ratio of the Aid flow (current US$) of Malta in 1994 to that in 1999?
Provide a short and direct response. 0.21. What is the ratio of the Aid flow (current US$) in Turkmenistan in 1994 to that in 1999?
Your answer should be very brief. 0.12. What is the ratio of the Aid flow (current US$) of Uzbekistan in 1994 to that in 1999?
Give a very brief answer. 0.03. What is the ratio of the Aid flow (current US$) in El Salvador in 1995 to that in 1996?
Your answer should be very brief. 0.69. What is the ratio of the Aid flow (current US$) of Malta in 1995 to that in 1996?
Offer a very short reply. 0.65. What is the ratio of the Aid flow (current US$) in Turkmenistan in 1995 to that in 1996?
Your answer should be compact. 0.73. What is the ratio of the Aid flow (current US$) in Uzbekistan in 1995 to that in 1996?
Provide a succinct answer. 0.63. What is the ratio of the Aid flow (current US$) of El Salvador in 1995 to that in 1997?
Your answer should be very brief. 0.71. What is the ratio of the Aid flow (current US$) of Malta in 1995 to that in 1997?
Your answer should be compact. 0.92. What is the ratio of the Aid flow (current US$) of Uzbekistan in 1995 to that in 1997?
Ensure brevity in your answer.  0.19. What is the ratio of the Aid flow (current US$) in El Salvador in 1995 to that in 1998?
Your response must be concise. 1.2. What is the ratio of the Aid flow (current US$) of Turkmenistan in 1995 to that in 1998?
Ensure brevity in your answer.  0.12. What is the ratio of the Aid flow (current US$) in Uzbekistan in 1995 to that in 1998?
Keep it short and to the point. 0.16. What is the ratio of the Aid flow (current US$) in El Salvador in 1995 to that in 1999?
Offer a very short reply. 0.92. What is the ratio of the Aid flow (current US$) of Turkmenistan in 1995 to that in 1999?
Give a very brief answer. 0.31. What is the ratio of the Aid flow (current US$) of Uzbekistan in 1995 to that in 1999?
Ensure brevity in your answer.  0.2. What is the ratio of the Aid flow (current US$) of El Salvador in 1996 to that in 1997?
Your answer should be compact. 1.03. What is the ratio of the Aid flow (current US$) of Malta in 1996 to that in 1997?
Your answer should be very brief. 1.42. What is the ratio of the Aid flow (current US$) of Turkmenistan in 1996 to that in 1997?
Ensure brevity in your answer.  0.91. What is the ratio of the Aid flow (current US$) of Uzbekistan in 1996 to that in 1997?
Ensure brevity in your answer.  0.3. What is the ratio of the Aid flow (current US$) in El Salvador in 1996 to that in 1998?
Provide a succinct answer. 1.73. What is the ratio of the Aid flow (current US$) in Malta in 1996 to that in 1998?
Provide a succinct answer. 1.32. What is the ratio of the Aid flow (current US$) of Turkmenistan in 1996 to that in 1998?
Offer a very short reply. 0.16. What is the ratio of the Aid flow (current US$) of Uzbekistan in 1996 to that in 1998?
Provide a short and direct response. 0.25. What is the ratio of the Aid flow (current US$) of El Salvador in 1996 to that in 1999?
Keep it short and to the point. 1.33. What is the ratio of the Aid flow (current US$) in Malta in 1996 to that in 1999?
Offer a terse response. 0.88. What is the ratio of the Aid flow (current US$) of Turkmenistan in 1996 to that in 1999?
Offer a very short reply. 0.42. What is the ratio of the Aid flow (current US$) in Uzbekistan in 1996 to that in 1999?
Ensure brevity in your answer.  0.31. What is the ratio of the Aid flow (current US$) in El Salvador in 1997 to that in 1998?
Give a very brief answer. 1.68. What is the ratio of the Aid flow (current US$) in Malta in 1997 to that in 1998?
Your answer should be compact. 0.93. What is the ratio of the Aid flow (current US$) of Turkmenistan in 1997 to that in 1998?
Your answer should be compact. 0.18. What is the ratio of the Aid flow (current US$) in Uzbekistan in 1997 to that in 1998?
Your answer should be very brief. 0.81. What is the ratio of the Aid flow (current US$) of El Salvador in 1997 to that in 1999?
Provide a succinct answer. 1.29. What is the ratio of the Aid flow (current US$) of Malta in 1997 to that in 1999?
Ensure brevity in your answer.  0.62. What is the ratio of the Aid flow (current US$) in Turkmenistan in 1997 to that in 1999?
Keep it short and to the point. 0.46. What is the ratio of the Aid flow (current US$) of Uzbekistan in 1997 to that in 1999?
Offer a terse response. 1.02. What is the ratio of the Aid flow (current US$) of El Salvador in 1998 to that in 1999?
Your answer should be compact. 0.77. What is the ratio of the Aid flow (current US$) in Malta in 1998 to that in 1999?
Give a very brief answer. 0.67. What is the ratio of the Aid flow (current US$) in Turkmenistan in 1998 to that in 1999?
Keep it short and to the point. 2.58. What is the ratio of the Aid flow (current US$) of Uzbekistan in 1998 to that in 1999?
Provide a succinct answer. 1.26. What is the difference between the highest and the second highest Aid flow (current US$) of El Salvador?
Provide a short and direct response. 2.15e+06. What is the difference between the highest and the second highest Aid flow (current US$) in Turkmenistan?
Make the answer very short. 2.67e+06. What is the difference between the highest and the second highest Aid flow (current US$) in Uzbekistan?
Offer a very short reply. 1.98e+07. What is the difference between the highest and the lowest Aid flow (current US$) of El Salvador?
Your response must be concise. 6.25e+07. What is the difference between the highest and the lowest Aid flow (current US$) of Turkmenistan?
Make the answer very short. 4.27e+06. What is the difference between the highest and the lowest Aid flow (current US$) in Uzbekistan?
Provide a succinct answer. 1.02e+08. 